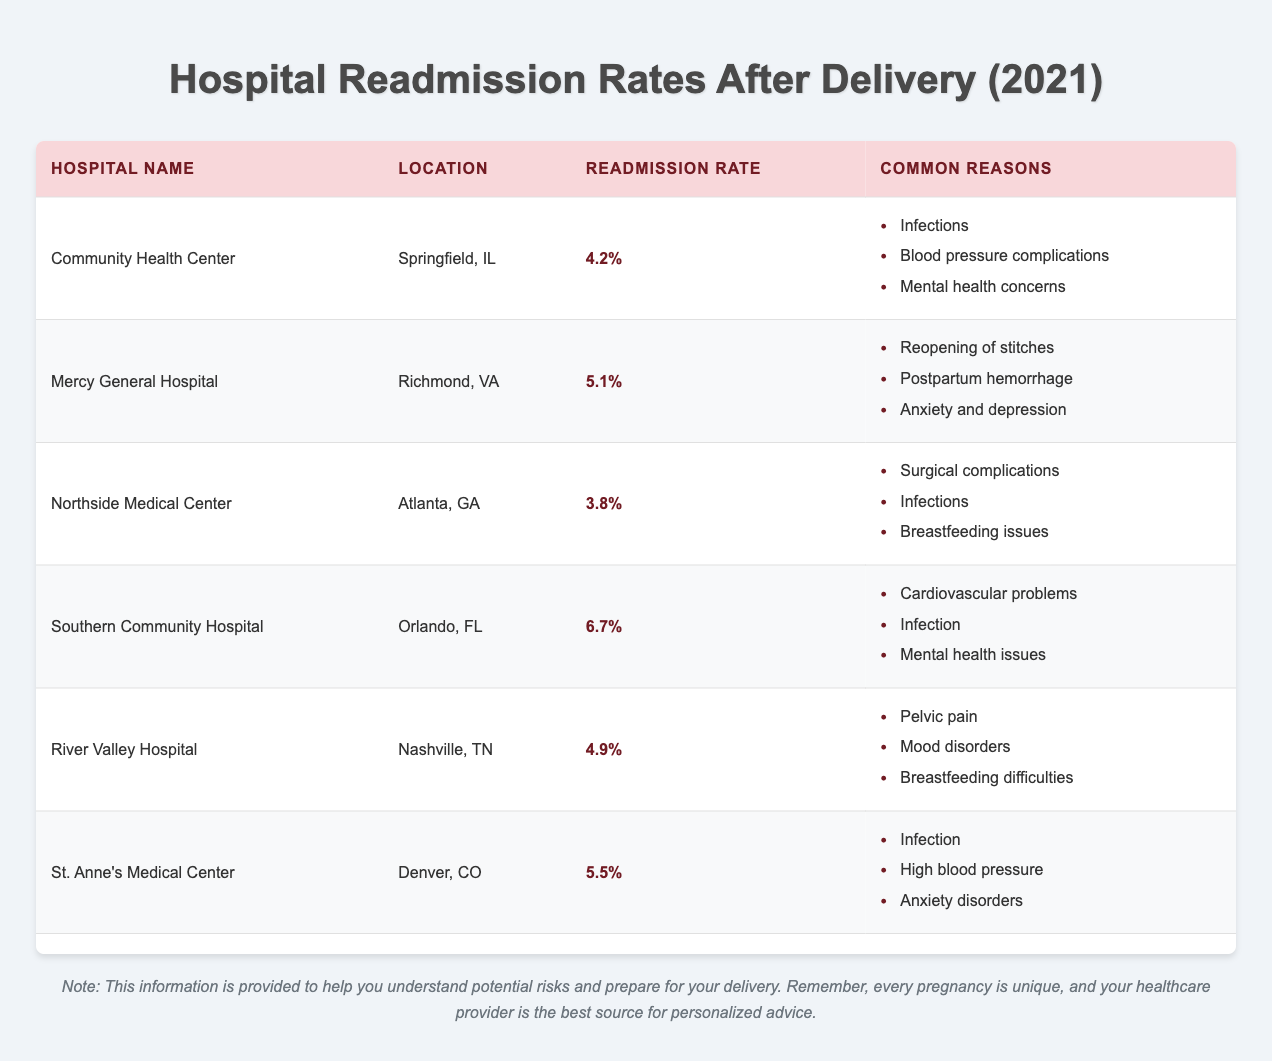What is the readmission rate for Community Health Center? The table indicates that the readmission rate for Community Health Center is listed directly next to its name. It is 4.2%.
Answer: 4.2% Which hospital has the highest readmission rate? In the table, I look at all the readmission rates listed under each hospital. The Southern Community Hospital has the highest rate at 6.7%.
Answer: 6.7% Are infections a common reason for readmission at Community Health Center? I check the list of common reasons for readmission next to Community Health Center in the table and see that infections are indeed mentioned as one of the reasons.
Answer: Yes What is the average readmission rate for all the hospitals listed? I sum all the readmission rates: (4.2 + 5.1 + 3.8 + 6.7 + 4.9 + 5.5) = 30.2. Then, I divide by the number of hospitals, which is 6. The average is 30.2 / 6 = 5.03%.
Answer: 5.03% Which two hospitals have readmission rates below 5%? Looking at the readmission rates in the table, I identify the hospitals below 5%. Community Health Center (4.2%) and Northside Medical Center (3.8%).
Answer: Community Health Center and Northside Medical Center What are the common readmission reasons for Mercy General Hospital? The table shows a list of common reasons for readmission next to Mercy General Hospital. It indicates reopening of stitches, postpartum hemorrhage, and anxiety and depression.
Answer: Reopening of stitches, postpartum hemorrhage, anxiety and depression Is there any hospital where anxiety or mental health issues are common reasons for readmission? I scan through the common reasons in the table and find that both Mercy General Hospital and Southern Community Hospital mention anxiety or mental health issues as reasons for readmission.
Answer: Yes Which hospital has a readmission rate of 5.5%, and what are its common reasons for readmission? I check the table for the hospital with a readmission rate of 5.5%. It is St. Anne's Medical Center, and the common reasons listed are infection, high blood pressure, and anxiety disorders.
Answer: St. Anne's Medical Center; infection, high blood pressure, anxiety disorders 